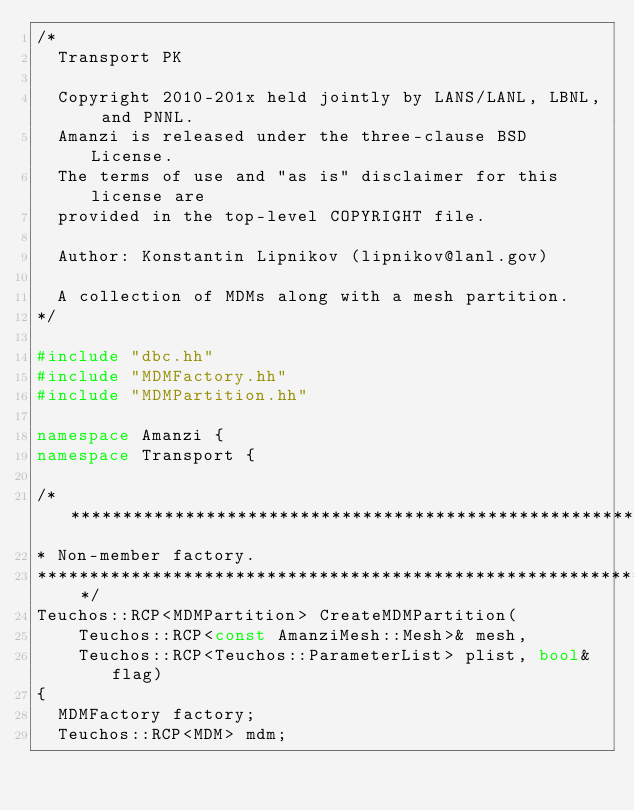Convert code to text. <code><loc_0><loc_0><loc_500><loc_500><_C++_>/*
  Transport PK 

  Copyright 2010-201x held jointly by LANS/LANL, LBNL, and PNNL. 
  Amanzi is released under the three-clause BSD License. 
  The terms of use and "as is" disclaimer for this license are 
  provided in the top-level COPYRIGHT file.

  Author: Konstantin Lipnikov (lipnikov@lanl.gov)

  A collection of MDMs along with a mesh partition.
*/

#include "dbc.hh"
#include "MDMFactory.hh"
#include "MDMPartition.hh"

namespace Amanzi {
namespace Transport {

/* ******************************************************************
* Non-member factory.
****************************************************************** */
Teuchos::RCP<MDMPartition> CreateMDMPartition(
    Teuchos::RCP<const AmanziMesh::Mesh>& mesh,
    Teuchos::RCP<Teuchos::ParameterList> plist, bool& flag)
{
  MDMFactory factory;
  Teuchos::RCP<MDM> mdm;</code> 